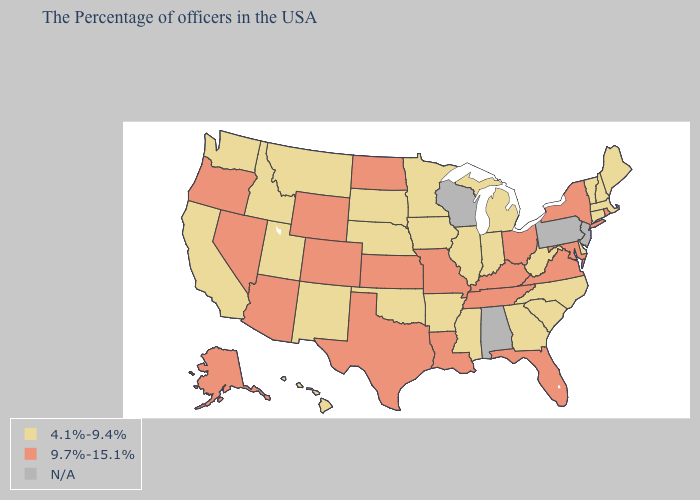Name the states that have a value in the range 4.1%-9.4%?
Write a very short answer. Maine, Massachusetts, New Hampshire, Vermont, Connecticut, Delaware, North Carolina, South Carolina, West Virginia, Georgia, Michigan, Indiana, Illinois, Mississippi, Arkansas, Minnesota, Iowa, Nebraska, Oklahoma, South Dakota, New Mexico, Utah, Montana, Idaho, California, Washington, Hawaii. Does New York have the highest value in the Northeast?
Concise answer only. Yes. Does the map have missing data?
Quick response, please. Yes. What is the value of Minnesota?
Short answer required. 4.1%-9.4%. What is the highest value in the South ?
Concise answer only. 9.7%-15.1%. Name the states that have a value in the range N/A?
Concise answer only. New Jersey, Pennsylvania, Alabama, Wisconsin. Name the states that have a value in the range 4.1%-9.4%?
Write a very short answer. Maine, Massachusetts, New Hampshire, Vermont, Connecticut, Delaware, North Carolina, South Carolina, West Virginia, Georgia, Michigan, Indiana, Illinois, Mississippi, Arkansas, Minnesota, Iowa, Nebraska, Oklahoma, South Dakota, New Mexico, Utah, Montana, Idaho, California, Washington, Hawaii. Among the states that border Utah , which have the lowest value?
Give a very brief answer. New Mexico, Idaho. What is the lowest value in the MidWest?
Keep it brief. 4.1%-9.4%. What is the value of Wyoming?
Answer briefly. 9.7%-15.1%. What is the value of Nebraska?
Short answer required. 4.1%-9.4%. What is the value of Illinois?
Short answer required. 4.1%-9.4%. Name the states that have a value in the range N/A?
Concise answer only. New Jersey, Pennsylvania, Alabama, Wisconsin. What is the value of Nevada?
Give a very brief answer. 9.7%-15.1%. Is the legend a continuous bar?
Short answer required. No. 